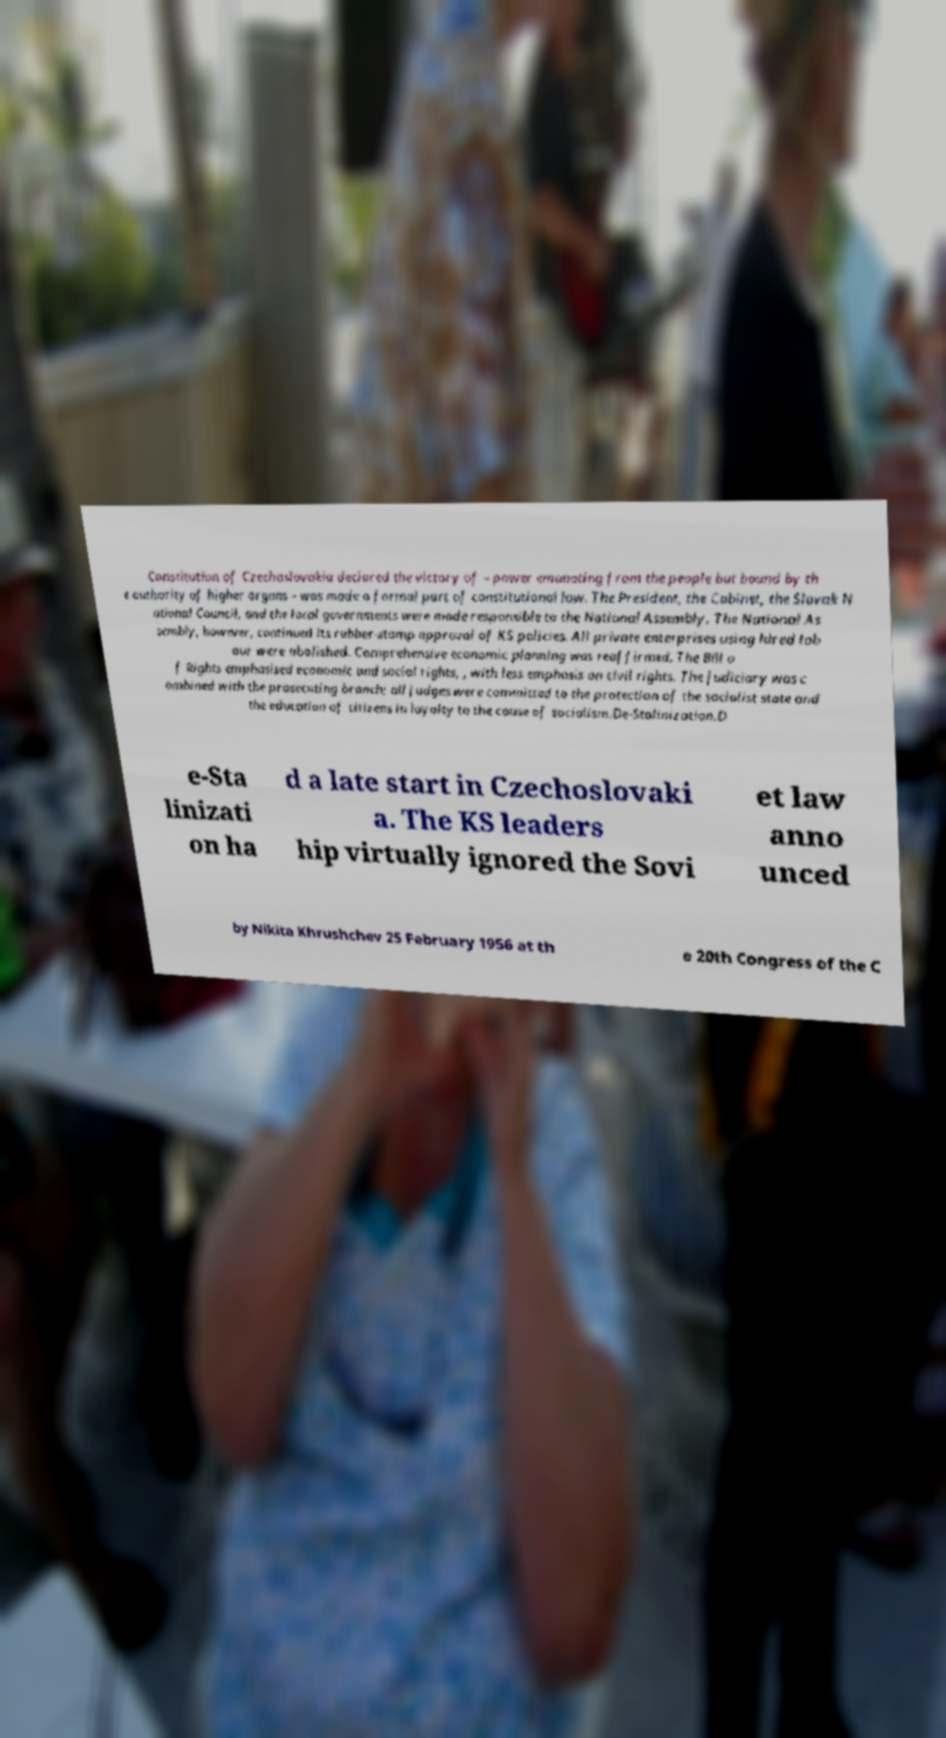There's text embedded in this image that I need extracted. Can you transcribe it verbatim? Constitution of Czechoslovakia declared the victory of – power emanating from the people but bound by th e authority of higher organs – was made a formal part of constitutional law. The President, the Cabinet, the Slovak N ational Council, and the local governments were made responsible to the National Assembly. The National As sembly, however, continued its rubber-stamp approval of KS policies. All private enterprises using hired lab our were abolished. Comprehensive economic planning was reaffirmed. The Bill o f Rights emphasised economic and social rights, , with less emphasis on civil rights. The judiciary was c ombined with the prosecuting branch; all judges were committed to the protection of the socialist state and the education of citizens in loyalty to the cause of socialism.De-Stalinization.D e-Sta linizati on ha d a late start in Czechoslovaki a. The KS leaders hip virtually ignored the Sovi et law anno unced by Nikita Khrushchev 25 February 1956 at th e 20th Congress of the C 